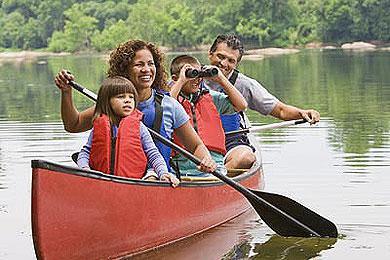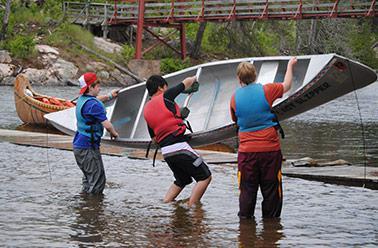The first image is the image on the left, the second image is the image on the right. Assess this claim about the two images: "One image shows people standing along one side of a canoe instead of sitting in it.". Correct or not? Answer yes or no. Yes. The first image is the image on the left, the second image is the image on the right. Evaluate the accuracy of this statement regarding the images: "In at least one of the images, people are shown outside of the canoe.". Is it true? Answer yes or no. Yes. 